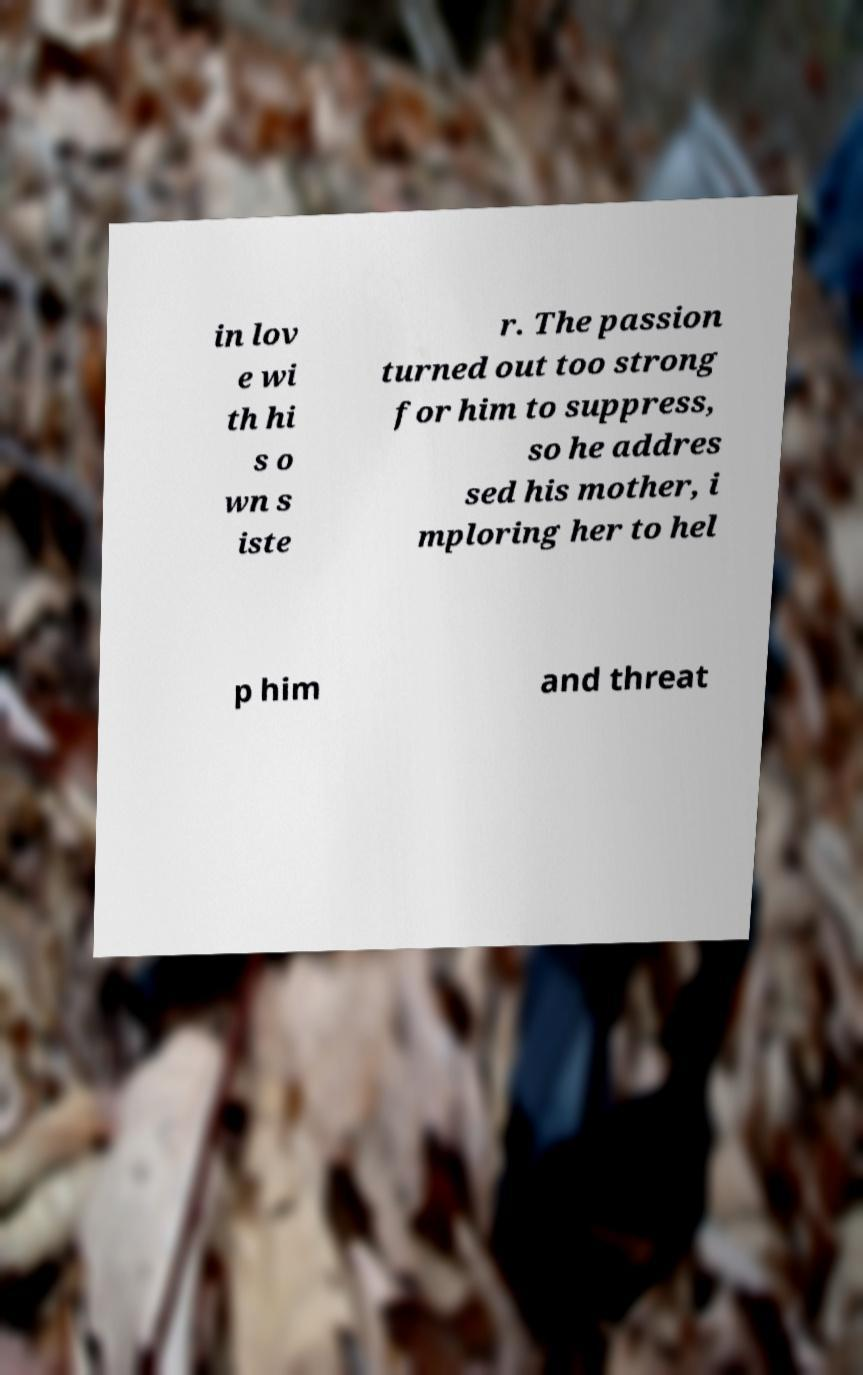For documentation purposes, I need the text within this image transcribed. Could you provide that? in lov e wi th hi s o wn s iste r. The passion turned out too strong for him to suppress, so he addres sed his mother, i mploring her to hel p him and threat 